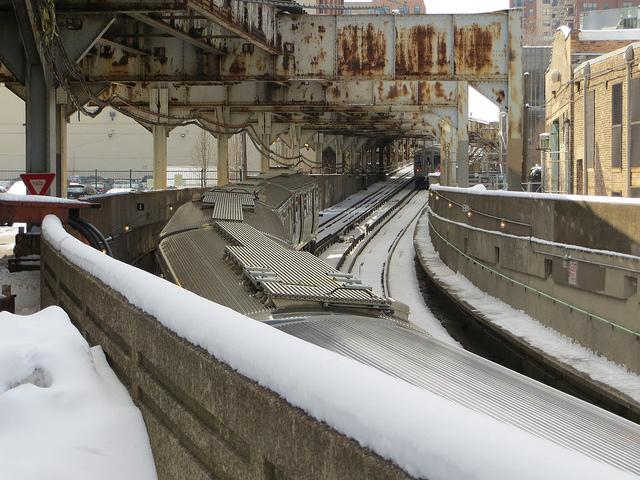What is located above the ironwork on top of the train that is heading away? Please explain your reasoning. train track. It's what the train runs on. 